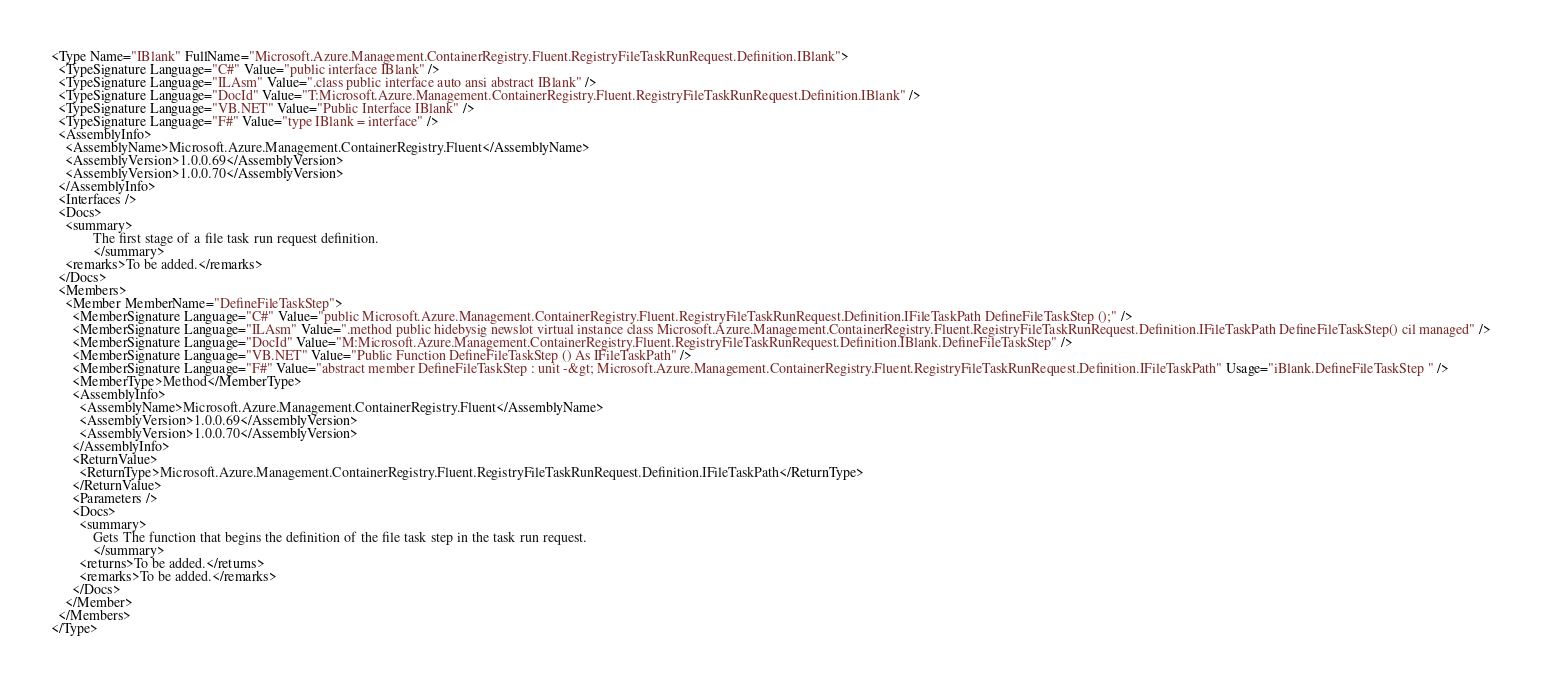<code> <loc_0><loc_0><loc_500><loc_500><_XML_><Type Name="IBlank" FullName="Microsoft.Azure.Management.ContainerRegistry.Fluent.RegistryFileTaskRunRequest.Definition.IBlank">
  <TypeSignature Language="C#" Value="public interface IBlank" />
  <TypeSignature Language="ILAsm" Value=".class public interface auto ansi abstract IBlank" />
  <TypeSignature Language="DocId" Value="T:Microsoft.Azure.Management.ContainerRegistry.Fluent.RegistryFileTaskRunRequest.Definition.IBlank" />
  <TypeSignature Language="VB.NET" Value="Public Interface IBlank" />
  <TypeSignature Language="F#" Value="type IBlank = interface" />
  <AssemblyInfo>
    <AssemblyName>Microsoft.Azure.Management.ContainerRegistry.Fluent</AssemblyName>
    <AssemblyVersion>1.0.0.69</AssemblyVersion>
    <AssemblyVersion>1.0.0.70</AssemblyVersion>
  </AssemblyInfo>
  <Interfaces />
  <Docs>
    <summary>
            The first stage of a file task run request definition.
            </summary>
    <remarks>To be added.</remarks>
  </Docs>
  <Members>
    <Member MemberName="DefineFileTaskStep">
      <MemberSignature Language="C#" Value="public Microsoft.Azure.Management.ContainerRegistry.Fluent.RegistryFileTaskRunRequest.Definition.IFileTaskPath DefineFileTaskStep ();" />
      <MemberSignature Language="ILAsm" Value=".method public hidebysig newslot virtual instance class Microsoft.Azure.Management.ContainerRegistry.Fluent.RegistryFileTaskRunRequest.Definition.IFileTaskPath DefineFileTaskStep() cil managed" />
      <MemberSignature Language="DocId" Value="M:Microsoft.Azure.Management.ContainerRegistry.Fluent.RegistryFileTaskRunRequest.Definition.IBlank.DefineFileTaskStep" />
      <MemberSignature Language="VB.NET" Value="Public Function DefineFileTaskStep () As IFileTaskPath" />
      <MemberSignature Language="F#" Value="abstract member DefineFileTaskStep : unit -&gt; Microsoft.Azure.Management.ContainerRegistry.Fluent.RegistryFileTaskRunRequest.Definition.IFileTaskPath" Usage="iBlank.DefineFileTaskStep " />
      <MemberType>Method</MemberType>
      <AssemblyInfo>
        <AssemblyName>Microsoft.Azure.Management.ContainerRegistry.Fluent</AssemblyName>
        <AssemblyVersion>1.0.0.69</AssemblyVersion>
        <AssemblyVersion>1.0.0.70</AssemblyVersion>
      </AssemblyInfo>
      <ReturnValue>
        <ReturnType>Microsoft.Azure.Management.ContainerRegistry.Fluent.RegistryFileTaskRunRequest.Definition.IFileTaskPath</ReturnType>
      </ReturnValue>
      <Parameters />
      <Docs>
        <summary>
            Gets The function that begins the definition of the file task step in the task run request.
            </summary>
        <returns>To be added.</returns>
        <remarks>To be added.</remarks>
      </Docs>
    </Member>
  </Members>
</Type>
</code> 